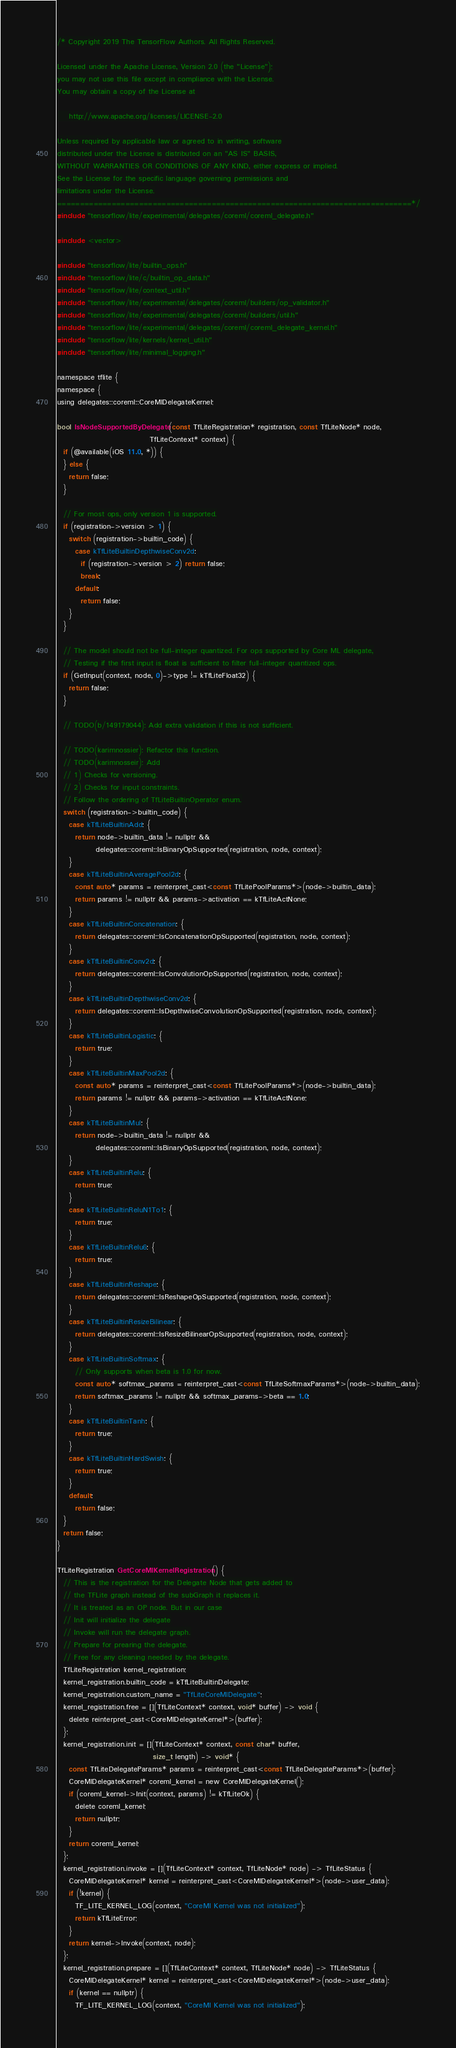Convert code to text. <code><loc_0><loc_0><loc_500><loc_500><_ObjectiveC_>/* Copyright 2019 The TensorFlow Authors. All Rights Reserved.

Licensed under the Apache License, Version 2.0 (the "License");
you may not use this file except in compliance with the License.
You may obtain a copy of the License at

    http://www.apache.org/licenses/LICENSE-2.0

Unless required by applicable law or agreed to in writing, software
distributed under the License is distributed on an "AS IS" BASIS,
WITHOUT WARRANTIES OR CONDITIONS OF ANY KIND, either express or implied.
See the License for the specific language governing permissions and
limitations under the License.
==============================================================================*/
#include "tensorflow/lite/experimental/delegates/coreml/coreml_delegate.h"

#include <vector>

#include "tensorflow/lite/builtin_ops.h"
#include "tensorflow/lite/c/builtin_op_data.h"
#include "tensorflow/lite/context_util.h"
#include "tensorflow/lite/experimental/delegates/coreml/builders/op_validator.h"
#include "tensorflow/lite/experimental/delegates/coreml/builders/util.h"
#include "tensorflow/lite/experimental/delegates/coreml/coreml_delegate_kernel.h"
#include "tensorflow/lite/kernels/kernel_util.h"
#include "tensorflow/lite/minimal_logging.h"

namespace tflite {
namespace {
using delegates::coreml::CoreMlDelegateKernel;

bool IsNodeSupportedByDelegate(const TfLiteRegistration* registration, const TfLiteNode* node,
                               TfLiteContext* context) {
  if (@available(iOS 11.0, *)) {
  } else {
    return false;
  }

  // For most ops, only version 1 is supported.
  if (registration->version > 1) {
    switch (registration->builtin_code) {
      case kTfLiteBuiltinDepthwiseConv2d:
        if (registration->version > 2) return false;
        break;
      default:
        return false;
    }
  }

  // The model should not be full-integer quantized. For ops supported by Core ML delegate,
  // Testing if the first input is float is sufficient to filter full-integer quantized ops.
  if (GetInput(context, node, 0)->type != kTfLiteFloat32) {
    return false;
  }

  // TODO(b/149179044): Add extra validation if this is not sufficient.

  // TODO(karimnossier): Refactor this function.
  // TODO(karimnosseir): Add
  // 1) Checks for versioning.
  // 2) Checks for input constraints.
  // Follow the ordering of TfLiteBuiltinOperator enum.
  switch (registration->builtin_code) {
    case kTfLiteBuiltinAdd: {
      return node->builtin_data != nullptr &&
             delegates::coreml::IsBinaryOpSupported(registration, node, context);
    }
    case kTfLiteBuiltinAveragePool2d: {
      const auto* params = reinterpret_cast<const TfLitePoolParams*>(node->builtin_data);
      return params != nullptr && params->activation == kTfLiteActNone;
    }
    case kTfLiteBuiltinConcatenation: {
      return delegates::coreml::IsConcatenationOpSupported(registration, node, context);
    }
    case kTfLiteBuiltinConv2d: {
      return delegates::coreml::IsConvolutionOpSupported(registration, node, context);
    }
    case kTfLiteBuiltinDepthwiseConv2d: {
      return delegates::coreml::IsDepthwiseConvolutionOpSupported(registration, node, context);
    }
    case kTfLiteBuiltinLogistic: {
      return true;
    }
    case kTfLiteBuiltinMaxPool2d: {
      const auto* params = reinterpret_cast<const TfLitePoolParams*>(node->builtin_data);
      return params != nullptr && params->activation == kTfLiteActNone;
    }
    case kTfLiteBuiltinMul: {
      return node->builtin_data != nullptr &&
             delegates::coreml::IsBinaryOpSupported(registration, node, context);
    }
    case kTfLiteBuiltinRelu: {
      return true;
    }
    case kTfLiteBuiltinReluN1To1: {
      return true;
    }
    case kTfLiteBuiltinRelu6: {
      return true;
    }
    case kTfLiteBuiltinReshape: {
      return delegates::coreml::IsReshapeOpSupported(registration, node, context);
    }
    case kTfLiteBuiltinResizeBilinear: {
      return delegates::coreml::IsResizeBilinearOpSupported(registration, node, context);
    }
    case kTfLiteBuiltinSoftmax: {
      // Only supports when beta is 1.0 for now.
      const auto* softmax_params = reinterpret_cast<const TfLiteSoftmaxParams*>(node->builtin_data);
      return softmax_params != nullptr && softmax_params->beta == 1.0;
    }
    case kTfLiteBuiltinTanh: {
      return true;
    }
    case kTfLiteBuiltinHardSwish: {
      return true;
    }
    default:
      return false;
  }
  return false;
}

TfLiteRegistration GetCoreMlKernelRegistration() {
  // This is the registration for the Delegate Node that gets added to
  // the TFLite graph instead of the subGraph it replaces it.
  // It is treated as an OP node. But in our case
  // Init will initialize the delegate
  // Invoke will run the delegate graph.
  // Prepare for prearing the delegate.
  // Free for any cleaning needed by the delegate.
  TfLiteRegistration kernel_registration;
  kernel_registration.builtin_code = kTfLiteBuiltinDelegate;
  kernel_registration.custom_name = "TfLiteCoreMlDelegate";
  kernel_registration.free = [](TfLiteContext* context, void* buffer) -> void {
    delete reinterpret_cast<CoreMlDelegateKernel*>(buffer);
  };
  kernel_registration.init = [](TfLiteContext* context, const char* buffer,
                                size_t length) -> void* {
    const TfLiteDelegateParams* params = reinterpret_cast<const TfLiteDelegateParams*>(buffer);
    CoreMlDelegateKernel* coreml_kernel = new CoreMlDelegateKernel();
    if (coreml_kernel->Init(context, params) != kTfLiteOk) {
      delete coreml_kernel;
      return nullptr;
    }
    return coreml_kernel;
  };
  kernel_registration.invoke = [](TfLiteContext* context, TfLiteNode* node) -> TfLiteStatus {
    CoreMlDelegateKernel* kernel = reinterpret_cast<CoreMlDelegateKernel*>(node->user_data);
    if (!kernel) {
      TF_LITE_KERNEL_LOG(context, "CoreMl Kernel was not initialized");
      return kTfLiteError;
    }
    return kernel->Invoke(context, node);
  };
  kernel_registration.prepare = [](TfLiteContext* context, TfLiteNode* node) -> TfLiteStatus {
    CoreMlDelegateKernel* kernel = reinterpret_cast<CoreMlDelegateKernel*>(node->user_data);
    if (kernel == nullptr) {
      TF_LITE_KERNEL_LOG(context, "CoreMl Kernel was not initialized");</code> 